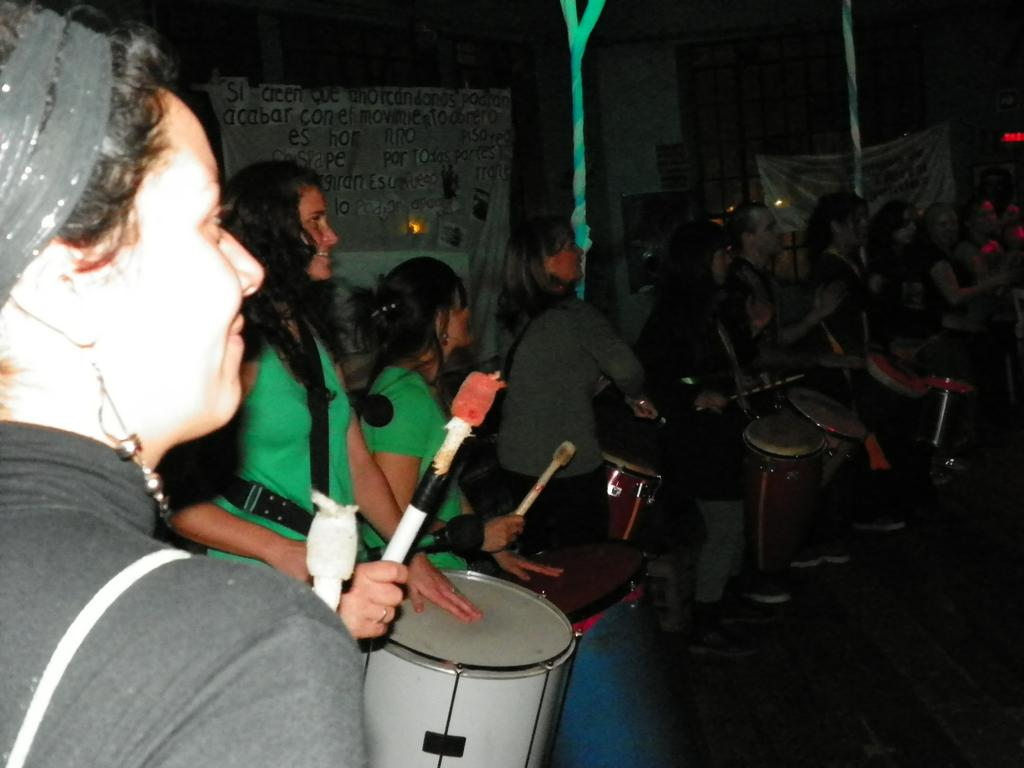What are the girls in the image doing? The girls in the image are playing drums. What type of clothing can be seen on most of the people in the image? Most of the people in the image are wearing t-shirts and pants. How would you describe the lighting in the image? The background of the image is dark. What type of underwear is visible on the people in the image? There is no visible underwear on the people in the image. Can you describe the digestive system of the drum set in the image? The drum set does not have a digestive system, as it is an inanimate object. 